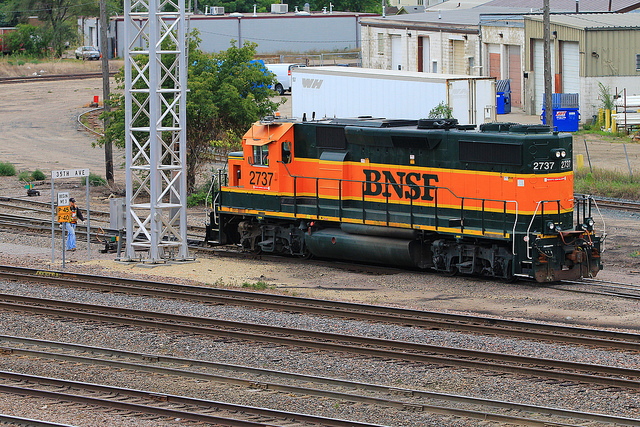Please transcribe the text in this image. BNSF 2737 2737 